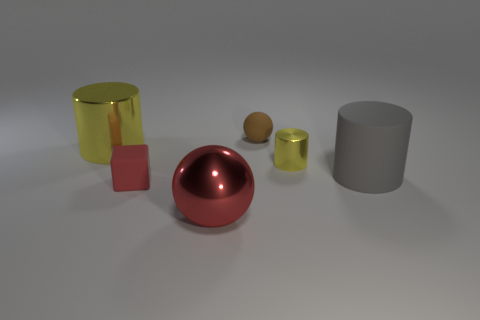There is a thing that is the same color as the tiny cylinder; what is it made of?
Keep it short and to the point. Metal. What is the color of the rubber cylinder that is the same size as the red sphere?
Provide a succinct answer. Gray. Do the brown matte sphere and the gray matte thing have the same size?
Your answer should be very brief. No. There is a matte object that is both in front of the tiny brown thing and to the left of the small cylinder; how big is it?
Provide a succinct answer. Small. What number of rubber things are either small cyan cubes or large red balls?
Your answer should be very brief. 0. Are there more metal things left of the red metal sphere than tiny brown cubes?
Offer a terse response. Yes. What is the yellow thing on the left side of the big red shiny object made of?
Provide a short and direct response. Metal. How many red spheres have the same material as the gray thing?
Provide a succinct answer. 0. There is a metallic thing that is both left of the small yellow shiny cylinder and behind the big red ball; what shape is it?
Offer a terse response. Cylinder. How many objects are either things that are in front of the gray rubber cylinder or things behind the large gray rubber object?
Provide a short and direct response. 5. 